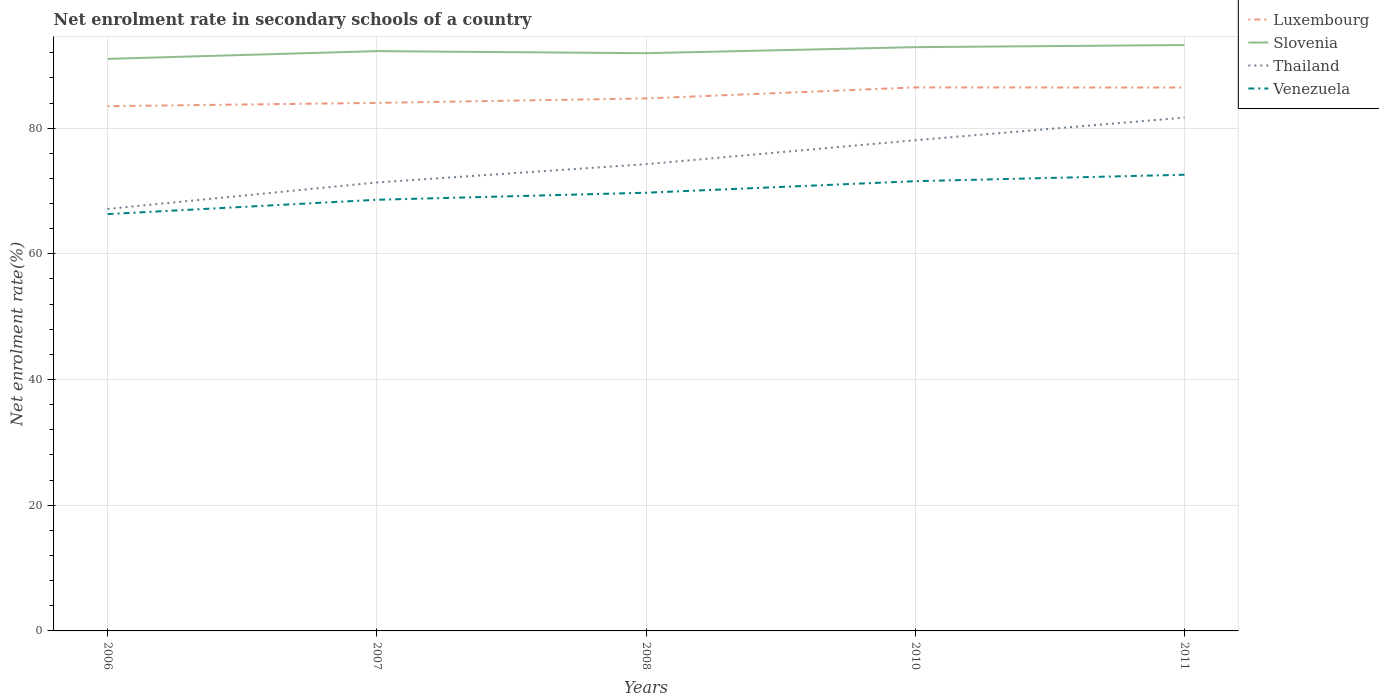How many different coloured lines are there?
Offer a terse response. 4. Does the line corresponding to Venezuela intersect with the line corresponding to Thailand?
Provide a succinct answer. No. Is the number of lines equal to the number of legend labels?
Ensure brevity in your answer.  Yes. Across all years, what is the maximum net enrolment rate in secondary schools in Venezuela?
Ensure brevity in your answer.  66.32. What is the total net enrolment rate in secondary schools in Venezuela in the graph?
Keep it short and to the point. -3.98. What is the difference between the highest and the second highest net enrolment rate in secondary schools in Slovenia?
Offer a very short reply. 2.2. What is the difference between the highest and the lowest net enrolment rate in secondary schools in Venezuela?
Give a very brief answer. 2. Is the net enrolment rate in secondary schools in Slovenia strictly greater than the net enrolment rate in secondary schools in Thailand over the years?
Give a very brief answer. No. How many lines are there?
Provide a short and direct response. 4. How many years are there in the graph?
Your response must be concise. 5. What is the difference between two consecutive major ticks on the Y-axis?
Offer a terse response. 20. Are the values on the major ticks of Y-axis written in scientific E-notation?
Provide a succinct answer. No. Does the graph contain any zero values?
Keep it short and to the point. No. Does the graph contain grids?
Offer a terse response. Yes. How many legend labels are there?
Keep it short and to the point. 4. How are the legend labels stacked?
Keep it short and to the point. Vertical. What is the title of the graph?
Your response must be concise. Net enrolment rate in secondary schools of a country. What is the label or title of the X-axis?
Provide a succinct answer. Years. What is the label or title of the Y-axis?
Ensure brevity in your answer.  Net enrolment rate(%). What is the Net enrolment rate(%) in Luxembourg in 2006?
Your response must be concise. 83.5. What is the Net enrolment rate(%) of Slovenia in 2006?
Make the answer very short. 91.03. What is the Net enrolment rate(%) of Thailand in 2006?
Your response must be concise. 67.15. What is the Net enrolment rate(%) of Venezuela in 2006?
Ensure brevity in your answer.  66.32. What is the Net enrolment rate(%) in Luxembourg in 2007?
Keep it short and to the point. 84.02. What is the Net enrolment rate(%) of Slovenia in 2007?
Make the answer very short. 92.26. What is the Net enrolment rate(%) in Thailand in 2007?
Your response must be concise. 71.36. What is the Net enrolment rate(%) of Venezuela in 2007?
Ensure brevity in your answer.  68.61. What is the Net enrolment rate(%) of Luxembourg in 2008?
Your response must be concise. 84.73. What is the Net enrolment rate(%) in Slovenia in 2008?
Make the answer very short. 91.93. What is the Net enrolment rate(%) of Thailand in 2008?
Provide a succinct answer. 74.27. What is the Net enrolment rate(%) of Venezuela in 2008?
Your answer should be compact. 69.73. What is the Net enrolment rate(%) in Luxembourg in 2010?
Your answer should be very brief. 86.49. What is the Net enrolment rate(%) in Slovenia in 2010?
Provide a succinct answer. 92.89. What is the Net enrolment rate(%) in Thailand in 2010?
Your answer should be very brief. 78.09. What is the Net enrolment rate(%) of Venezuela in 2010?
Give a very brief answer. 71.57. What is the Net enrolment rate(%) in Luxembourg in 2011?
Your answer should be compact. 86.47. What is the Net enrolment rate(%) in Slovenia in 2011?
Your answer should be very brief. 93.23. What is the Net enrolment rate(%) of Thailand in 2011?
Ensure brevity in your answer.  81.69. What is the Net enrolment rate(%) in Venezuela in 2011?
Give a very brief answer. 72.59. Across all years, what is the maximum Net enrolment rate(%) in Luxembourg?
Give a very brief answer. 86.49. Across all years, what is the maximum Net enrolment rate(%) in Slovenia?
Your response must be concise. 93.23. Across all years, what is the maximum Net enrolment rate(%) of Thailand?
Offer a terse response. 81.69. Across all years, what is the maximum Net enrolment rate(%) in Venezuela?
Keep it short and to the point. 72.59. Across all years, what is the minimum Net enrolment rate(%) in Luxembourg?
Offer a very short reply. 83.5. Across all years, what is the minimum Net enrolment rate(%) of Slovenia?
Keep it short and to the point. 91.03. Across all years, what is the minimum Net enrolment rate(%) in Thailand?
Your answer should be very brief. 67.15. Across all years, what is the minimum Net enrolment rate(%) of Venezuela?
Offer a very short reply. 66.32. What is the total Net enrolment rate(%) of Luxembourg in the graph?
Your answer should be very brief. 425.21. What is the total Net enrolment rate(%) in Slovenia in the graph?
Keep it short and to the point. 461.34. What is the total Net enrolment rate(%) of Thailand in the graph?
Offer a terse response. 372.56. What is the total Net enrolment rate(%) of Venezuela in the graph?
Offer a terse response. 348.82. What is the difference between the Net enrolment rate(%) of Luxembourg in 2006 and that in 2007?
Your answer should be very brief. -0.52. What is the difference between the Net enrolment rate(%) of Slovenia in 2006 and that in 2007?
Give a very brief answer. -1.23. What is the difference between the Net enrolment rate(%) in Thailand in 2006 and that in 2007?
Your answer should be very brief. -4.21. What is the difference between the Net enrolment rate(%) of Venezuela in 2006 and that in 2007?
Your answer should be compact. -2.28. What is the difference between the Net enrolment rate(%) of Luxembourg in 2006 and that in 2008?
Ensure brevity in your answer.  -1.23. What is the difference between the Net enrolment rate(%) in Slovenia in 2006 and that in 2008?
Your answer should be compact. -0.9. What is the difference between the Net enrolment rate(%) of Thailand in 2006 and that in 2008?
Keep it short and to the point. -7.12. What is the difference between the Net enrolment rate(%) of Venezuela in 2006 and that in 2008?
Provide a succinct answer. -3.4. What is the difference between the Net enrolment rate(%) of Luxembourg in 2006 and that in 2010?
Give a very brief answer. -2.99. What is the difference between the Net enrolment rate(%) in Slovenia in 2006 and that in 2010?
Your answer should be compact. -1.86. What is the difference between the Net enrolment rate(%) of Thailand in 2006 and that in 2010?
Ensure brevity in your answer.  -10.94. What is the difference between the Net enrolment rate(%) in Venezuela in 2006 and that in 2010?
Give a very brief answer. -5.24. What is the difference between the Net enrolment rate(%) of Luxembourg in 2006 and that in 2011?
Offer a very short reply. -2.97. What is the difference between the Net enrolment rate(%) of Slovenia in 2006 and that in 2011?
Your response must be concise. -2.2. What is the difference between the Net enrolment rate(%) of Thailand in 2006 and that in 2011?
Your answer should be very brief. -14.54. What is the difference between the Net enrolment rate(%) in Venezuela in 2006 and that in 2011?
Offer a terse response. -6.27. What is the difference between the Net enrolment rate(%) in Luxembourg in 2007 and that in 2008?
Provide a succinct answer. -0.71. What is the difference between the Net enrolment rate(%) of Slovenia in 2007 and that in 2008?
Your answer should be very brief. 0.33. What is the difference between the Net enrolment rate(%) in Thailand in 2007 and that in 2008?
Give a very brief answer. -2.91. What is the difference between the Net enrolment rate(%) of Venezuela in 2007 and that in 2008?
Your response must be concise. -1.12. What is the difference between the Net enrolment rate(%) of Luxembourg in 2007 and that in 2010?
Ensure brevity in your answer.  -2.46. What is the difference between the Net enrolment rate(%) in Slovenia in 2007 and that in 2010?
Your response must be concise. -0.63. What is the difference between the Net enrolment rate(%) of Thailand in 2007 and that in 2010?
Provide a short and direct response. -6.72. What is the difference between the Net enrolment rate(%) in Venezuela in 2007 and that in 2010?
Keep it short and to the point. -2.96. What is the difference between the Net enrolment rate(%) in Luxembourg in 2007 and that in 2011?
Provide a succinct answer. -2.44. What is the difference between the Net enrolment rate(%) in Slovenia in 2007 and that in 2011?
Give a very brief answer. -0.97. What is the difference between the Net enrolment rate(%) of Thailand in 2007 and that in 2011?
Give a very brief answer. -10.32. What is the difference between the Net enrolment rate(%) of Venezuela in 2007 and that in 2011?
Your answer should be compact. -3.98. What is the difference between the Net enrolment rate(%) of Luxembourg in 2008 and that in 2010?
Your answer should be very brief. -1.75. What is the difference between the Net enrolment rate(%) in Slovenia in 2008 and that in 2010?
Offer a very short reply. -0.96. What is the difference between the Net enrolment rate(%) of Thailand in 2008 and that in 2010?
Offer a terse response. -3.81. What is the difference between the Net enrolment rate(%) of Venezuela in 2008 and that in 2010?
Offer a very short reply. -1.84. What is the difference between the Net enrolment rate(%) in Luxembourg in 2008 and that in 2011?
Give a very brief answer. -1.73. What is the difference between the Net enrolment rate(%) in Slovenia in 2008 and that in 2011?
Give a very brief answer. -1.3. What is the difference between the Net enrolment rate(%) in Thailand in 2008 and that in 2011?
Ensure brevity in your answer.  -7.41. What is the difference between the Net enrolment rate(%) of Venezuela in 2008 and that in 2011?
Give a very brief answer. -2.86. What is the difference between the Net enrolment rate(%) in Luxembourg in 2010 and that in 2011?
Offer a very short reply. 0.02. What is the difference between the Net enrolment rate(%) of Slovenia in 2010 and that in 2011?
Offer a very short reply. -0.34. What is the difference between the Net enrolment rate(%) in Thailand in 2010 and that in 2011?
Your response must be concise. -3.6. What is the difference between the Net enrolment rate(%) in Venezuela in 2010 and that in 2011?
Offer a very short reply. -1.03. What is the difference between the Net enrolment rate(%) in Luxembourg in 2006 and the Net enrolment rate(%) in Slovenia in 2007?
Make the answer very short. -8.76. What is the difference between the Net enrolment rate(%) in Luxembourg in 2006 and the Net enrolment rate(%) in Thailand in 2007?
Ensure brevity in your answer.  12.14. What is the difference between the Net enrolment rate(%) in Luxembourg in 2006 and the Net enrolment rate(%) in Venezuela in 2007?
Provide a succinct answer. 14.89. What is the difference between the Net enrolment rate(%) of Slovenia in 2006 and the Net enrolment rate(%) of Thailand in 2007?
Offer a very short reply. 19.66. What is the difference between the Net enrolment rate(%) of Slovenia in 2006 and the Net enrolment rate(%) of Venezuela in 2007?
Provide a short and direct response. 22.42. What is the difference between the Net enrolment rate(%) of Thailand in 2006 and the Net enrolment rate(%) of Venezuela in 2007?
Keep it short and to the point. -1.46. What is the difference between the Net enrolment rate(%) of Luxembourg in 2006 and the Net enrolment rate(%) of Slovenia in 2008?
Provide a short and direct response. -8.43. What is the difference between the Net enrolment rate(%) of Luxembourg in 2006 and the Net enrolment rate(%) of Thailand in 2008?
Give a very brief answer. 9.23. What is the difference between the Net enrolment rate(%) of Luxembourg in 2006 and the Net enrolment rate(%) of Venezuela in 2008?
Offer a very short reply. 13.77. What is the difference between the Net enrolment rate(%) of Slovenia in 2006 and the Net enrolment rate(%) of Thailand in 2008?
Offer a terse response. 16.75. What is the difference between the Net enrolment rate(%) of Slovenia in 2006 and the Net enrolment rate(%) of Venezuela in 2008?
Provide a short and direct response. 21.3. What is the difference between the Net enrolment rate(%) in Thailand in 2006 and the Net enrolment rate(%) in Venezuela in 2008?
Provide a short and direct response. -2.58. What is the difference between the Net enrolment rate(%) of Luxembourg in 2006 and the Net enrolment rate(%) of Slovenia in 2010?
Ensure brevity in your answer.  -9.39. What is the difference between the Net enrolment rate(%) of Luxembourg in 2006 and the Net enrolment rate(%) of Thailand in 2010?
Offer a very short reply. 5.41. What is the difference between the Net enrolment rate(%) of Luxembourg in 2006 and the Net enrolment rate(%) of Venezuela in 2010?
Ensure brevity in your answer.  11.93. What is the difference between the Net enrolment rate(%) of Slovenia in 2006 and the Net enrolment rate(%) of Thailand in 2010?
Keep it short and to the point. 12.94. What is the difference between the Net enrolment rate(%) of Slovenia in 2006 and the Net enrolment rate(%) of Venezuela in 2010?
Provide a succinct answer. 19.46. What is the difference between the Net enrolment rate(%) in Thailand in 2006 and the Net enrolment rate(%) in Venezuela in 2010?
Give a very brief answer. -4.42. What is the difference between the Net enrolment rate(%) of Luxembourg in 2006 and the Net enrolment rate(%) of Slovenia in 2011?
Your answer should be compact. -9.73. What is the difference between the Net enrolment rate(%) of Luxembourg in 2006 and the Net enrolment rate(%) of Thailand in 2011?
Your response must be concise. 1.81. What is the difference between the Net enrolment rate(%) of Luxembourg in 2006 and the Net enrolment rate(%) of Venezuela in 2011?
Your answer should be compact. 10.91. What is the difference between the Net enrolment rate(%) of Slovenia in 2006 and the Net enrolment rate(%) of Thailand in 2011?
Provide a short and direct response. 9.34. What is the difference between the Net enrolment rate(%) in Slovenia in 2006 and the Net enrolment rate(%) in Venezuela in 2011?
Give a very brief answer. 18.44. What is the difference between the Net enrolment rate(%) in Thailand in 2006 and the Net enrolment rate(%) in Venezuela in 2011?
Offer a terse response. -5.44. What is the difference between the Net enrolment rate(%) in Luxembourg in 2007 and the Net enrolment rate(%) in Slovenia in 2008?
Your answer should be very brief. -7.91. What is the difference between the Net enrolment rate(%) in Luxembourg in 2007 and the Net enrolment rate(%) in Thailand in 2008?
Offer a very short reply. 9.75. What is the difference between the Net enrolment rate(%) in Luxembourg in 2007 and the Net enrolment rate(%) in Venezuela in 2008?
Offer a very short reply. 14.3. What is the difference between the Net enrolment rate(%) in Slovenia in 2007 and the Net enrolment rate(%) in Thailand in 2008?
Offer a very short reply. 17.99. What is the difference between the Net enrolment rate(%) of Slovenia in 2007 and the Net enrolment rate(%) of Venezuela in 2008?
Offer a very short reply. 22.53. What is the difference between the Net enrolment rate(%) in Thailand in 2007 and the Net enrolment rate(%) in Venezuela in 2008?
Offer a terse response. 1.63. What is the difference between the Net enrolment rate(%) of Luxembourg in 2007 and the Net enrolment rate(%) of Slovenia in 2010?
Your answer should be compact. -8.87. What is the difference between the Net enrolment rate(%) in Luxembourg in 2007 and the Net enrolment rate(%) in Thailand in 2010?
Your answer should be compact. 5.94. What is the difference between the Net enrolment rate(%) in Luxembourg in 2007 and the Net enrolment rate(%) in Venezuela in 2010?
Offer a terse response. 12.46. What is the difference between the Net enrolment rate(%) in Slovenia in 2007 and the Net enrolment rate(%) in Thailand in 2010?
Provide a short and direct response. 14.17. What is the difference between the Net enrolment rate(%) in Slovenia in 2007 and the Net enrolment rate(%) in Venezuela in 2010?
Make the answer very short. 20.7. What is the difference between the Net enrolment rate(%) of Thailand in 2007 and the Net enrolment rate(%) of Venezuela in 2010?
Ensure brevity in your answer.  -0.2. What is the difference between the Net enrolment rate(%) of Luxembourg in 2007 and the Net enrolment rate(%) of Slovenia in 2011?
Make the answer very short. -9.21. What is the difference between the Net enrolment rate(%) in Luxembourg in 2007 and the Net enrolment rate(%) in Thailand in 2011?
Offer a terse response. 2.34. What is the difference between the Net enrolment rate(%) of Luxembourg in 2007 and the Net enrolment rate(%) of Venezuela in 2011?
Give a very brief answer. 11.43. What is the difference between the Net enrolment rate(%) in Slovenia in 2007 and the Net enrolment rate(%) in Thailand in 2011?
Provide a short and direct response. 10.57. What is the difference between the Net enrolment rate(%) in Slovenia in 2007 and the Net enrolment rate(%) in Venezuela in 2011?
Your answer should be compact. 19.67. What is the difference between the Net enrolment rate(%) in Thailand in 2007 and the Net enrolment rate(%) in Venezuela in 2011?
Ensure brevity in your answer.  -1.23. What is the difference between the Net enrolment rate(%) of Luxembourg in 2008 and the Net enrolment rate(%) of Slovenia in 2010?
Give a very brief answer. -8.16. What is the difference between the Net enrolment rate(%) in Luxembourg in 2008 and the Net enrolment rate(%) in Thailand in 2010?
Your answer should be very brief. 6.65. What is the difference between the Net enrolment rate(%) of Luxembourg in 2008 and the Net enrolment rate(%) of Venezuela in 2010?
Your response must be concise. 13.17. What is the difference between the Net enrolment rate(%) of Slovenia in 2008 and the Net enrolment rate(%) of Thailand in 2010?
Your answer should be compact. 13.85. What is the difference between the Net enrolment rate(%) of Slovenia in 2008 and the Net enrolment rate(%) of Venezuela in 2010?
Make the answer very short. 20.37. What is the difference between the Net enrolment rate(%) of Thailand in 2008 and the Net enrolment rate(%) of Venezuela in 2010?
Your answer should be compact. 2.71. What is the difference between the Net enrolment rate(%) in Luxembourg in 2008 and the Net enrolment rate(%) in Slovenia in 2011?
Provide a succinct answer. -8.5. What is the difference between the Net enrolment rate(%) of Luxembourg in 2008 and the Net enrolment rate(%) of Thailand in 2011?
Keep it short and to the point. 3.05. What is the difference between the Net enrolment rate(%) of Luxembourg in 2008 and the Net enrolment rate(%) of Venezuela in 2011?
Offer a very short reply. 12.14. What is the difference between the Net enrolment rate(%) in Slovenia in 2008 and the Net enrolment rate(%) in Thailand in 2011?
Ensure brevity in your answer.  10.24. What is the difference between the Net enrolment rate(%) of Slovenia in 2008 and the Net enrolment rate(%) of Venezuela in 2011?
Provide a succinct answer. 19.34. What is the difference between the Net enrolment rate(%) of Thailand in 2008 and the Net enrolment rate(%) of Venezuela in 2011?
Your answer should be compact. 1.68. What is the difference between the Net enrolment rate(%) of Luxembourg in 2010 and the Net enrolment rate(%) of Slovenia in 2011?
Your response must be concise. -6.75. What is the difference between the Net enrolment rate(%) of Luxembourg in 2010 and the Net enrolment rate(%) of Thailand in 2011?
Your response must be concise. 4.8. What is the difference between the Net enrolment rate(%) in Luxembourg in 2010 and the Net enrolment rate(%) in Venezuela in 2011?
Give a very brief answer. 13.89. What is the difference between the Net enrolment rate(%) in Slovenia in 2010 and the Net enrolment rate(%) in Thailand in 2011?
Ensure brevity in your answer.  11.21. What is the difference between the Net enrolment rate(%) of Slovenia in 2010 and the Net enrolment rate(%) of Venezuela in 2011?
Offer a very short reply. 20.3. What is the difference between the Net enrolment rate(%) in Thailand in 2010 and the Net enrolment rate(%) in Venezuela in 2011?
Your response must be concise. 5.5. What is the average Net enrolment rate(%) in Luxembourg per year?
Give a very brief answer. 85.04. What is the average Net enrolment rate(%) in Slovenia per year?
Offer a terse response. 92.27. What is the average Net enrolment rate(%) of Thailand per year?
Offer a very short reply. 74.51. What is the average Net enrolment rate(%) in Venezuela per year?
Make the answer very short. 69.76. In the year 2006, what is the difference between the Net enrolment rate(%) of Luxembourg and Net enrolment rate(%) of Slovenia?
Make the answer very short. -7.53. In the year 2006, what is the difference between the Net enrolment rate(%) in Luxembourg and Net enrolment rate(%) in Thailand?
Offer a terse response. 16.35. In the year 2006, what is the difference between the Net enrolment rate(%) in Luxembourg and Net enrolment rate(%) in Venezuela?
Keep it short and to the point. 17.18. In the year 2006, what is the difference between the Net enrolment rate(%) in Slovenia and Net enrolment rate(%) in Thailand?
Offer a very short reply. 23.88. In the year 2006, what is the difference between the Net enrolment rate(%) in Slovenia and Net enrolment rate(%) in Venezuela?
Your response must be concise. 24.7. In the year 2006, what is the difference between the Net enrolment rate(%) in Thailand and Net enrolment rate(%) in Venezuela?
Make the answer very short. 0.82. In the year 2007, what is the difference between the Net enrolment rate(%) in Luxembourg and Net enrolment rate(%) in Slovenia?
Provide a short and direct response. -8.24. In the year 2007, what is the difference between the Net enrolment rate(%) of Luxembourg and Net enrolment rate(%) of Thailand?
Provide a succinct answer. 12.66. In the year 2007, what is the difference between the Net enrolment rate(%) in Luxembourg and Net enrolment rate(%) in Venezuela?
Offer a terse response. 15.42. In the year 2007, what is the difference between the Net enrolment rate(%) of Slovenia and Net enrolment rate(%) of Thailand?
Make the answer very short. 20.9. In the year 2007, what is the difference between the Net enrolment rate(%) in Slovenia and Net enrolment rate(%) in Venezuela?
Offer a very short reply. 23.65. In the year 2007, what is the difference between the Net enrolment rate(%) of Thailand and Net enrolment rate(%) of Venezuela?
Keep it short and to the point. 2.75. In the year 2008, what is the difference between the Net enrolment rate(%) of Luxembourg and Net enrolment rate(%) of Slovenia?
Offer a very short reply. -7.2. In the year 2008, what is the difference between the Net enrolment rate(%) of Luxembourg and Net enrolment rate(%) of Thailand?
Your answer should be compact. 10.46. In the year 2008, what is the difference between the Net enrolment rate(%) of Luxembourg and Net enrolment rate(%) of Venezuela?
Provide a short and direct response. 15.01. In the year 2008, what is the difference between the Net enrolment rate(%) of Slovenia and Net enrolment rate(%) of Thailand?
Ensure brevity in your answer.  17.66. In the year 2008, what is the difference between the Net enrolment rate(%) of Slovenia and Net enrolment rate(%) of Venezuela?
Your answer should be compact. 22.2. In the year 2008, what is the difference between the Net enrolment rate(%) of Thailand and Net enrolment rate(%) of Venezuela?
Your answer should be very brief. 4.54. In the year 2010, what is the difference between the Net enrolment rate(%) of Luxembourg and Net enrolment rate(%) of Slovenia?
Provide a short and direct response. -6.41. In the year 2010, what is the difference between the Net enrolment rate(%) in Luxembourg and Net enrolment rate(%) in Thailand?
Your answer should be very brief. 8.4. In the year 2010, what is the difference between the Net enrolment rate(%) in Luxembourg and Net enrolment rate(%) in Venezuela?
Ensure brevity in your answer.  14.92. In the year 2010, what is the difference between the Net enrolment rate(%) in Slovenia and Net enrolment rate(%) in Thailand?
Provide a succinct answer. 14.81. In the year 2010, what is the difference between the Net enrolment rate(%) of Slovenia and Net enrolment rate(%) of Venezuela?
Offer a terse response. 21.33. In the year 2010, what is the difference between the Net enrolment rate(%) in Thailand and Net enrolment rate(%) in Venezuela?
Your answer should be compact. 6.52. In the year 2011, what is the difference between the Net enrolment rate(%) of Luxembourg and Net enrolment rate(%) of Slovenia?
Offer a very short reply. -6.76. In the year 2011, what is the difference between the Net enrolment rate(%) of Luxembourg and Net enrolment rate(%) of Thailand?
Provide a succinct answer. 4.78. In the year 2011, what is the difference between the Net enrolment rate(%) in Luxembourg and Net enrolment rate(%) in Venezuela?
Provide a short and direct response. 13.88. In the year 2011, what is the difference between the Net enrolment rate(%) in Slovenia and Net enrolment rate(%) in Thailand?
Make the answer very short. 11.54. In the year 2011, what is the difference between the Net enrolment rate(%) of Slovenia and Net enrolment rate(%) of Venezuela?
Make the answer very short. 20.64. In the year 2011, what is the difference between the Net enrolment rate(%) in Thailand and Net enrolment rate(%) in Venezuela?
Make the answer very short. 9.1. What is the ratio of the Net enrolment rate(%) of Slovenia in 2006 to that in 2007?
Offer a terse response. 0.99. What is the ratio of the Net enrolment rate(%) of Thailand in 2006 to that in 2007?
Keep it short and to the point. 0.94. What is the ratio of the Net enrolment rate(%) in Venezuela in 2006 to that in 2007?
Your answer should be compact. 0.97. What is the ratio of the Net enrolment rate(%) in Luxembourg in 2006 to that in 2008?
Provide a short and direct response. 0.99. What is the ratio of the Net enrolment rate(%) in Slovenia in 2006 to that in 2008?
Offer a very short reply. 0.99. What is the ratio of the Net enrolment rate(%) of Thailand in 2006 to that in 2008?
Make the answer very short. 0.9. What is the ratio of the Net enrolment rate(%) of Venezuela in 2006 to that in 2008?
Your answer should be very brief. 0.95. What is the ratio of the Net enrolment rate(%) of Luxembourg in 2006 to that in 2010?
Your answer should be very brief. 0.97. What is the ratio of the Net enrolment rate(%) of Slovenia in 2006 to that in 2010?
Provide a succinct answer. 0.98. What is the ratio of the Net enrolment rate(%) of Thailand in 2006 to that in 2010?
Make the answer very short. 0.86. What is the ratio of the Net enrolment rate(%) of Venezuela in 2006 to that in 2010?
Offer a terse response. 0.93. What is the ratio of the Net enrolment rate(%) in Luxembourg in 2006 to that in 2011?
Provide a succinct answer. 0.97. What is the ratio of the Net enrolment rate(%) of Slovenia in 2006 to that in 2011?
Make the answer very short. 0.98. What is the ratio of the Net enrolment rate(%) in Thailand in 2006 to that in 2011?
Ensure brevity in your answer.  0.82. What is the ratio of the Net enrolment rate(%) of Venezuela in 2006 to that in 2011?
Provide a succinct answer. 0.91. What is the ratio of the Net enrolment rate(%) of Luxembourg in 2007 to that in 2008?
Give a very brief answer. 0.99. What is the ratio of the Net enrolment rate(%) of Slovenia in 2007 to that in 2008?
Your answer should be compact. 1. What is the ratio of the Net enrolment rate(%) in Thailand in 2007 to that in 2008?
Give a very brief answer. 0.96. What is the ratio of the Net enrolment rate(%) in Venezuela in 2007 to that in 2008?
Ensure brevity in your answer.  0.98. What is the ratio of the Net enrolment rate(%) of Luxembourg in 2007 to that in 2010?
Provide a short and direct response. 0.97. What is the ratio of the Net enrolment rate(%) of Slovenia in 2007 to that in 2010?
Make the answer very short. 0.99. What is the ratio of the Net enrolment rate(%) of Thailand in 2007 to that in 2010?
Make the answer very short. 0.91. What is the ratio of the Net enrolment rate(%) of Venezuela in 2007 to that in 2010?
Offer a very short reply. 0.96. What is the ratio of the Net enrolment rate(%) of Luxembourg in 2007 to that in 2011?
Provide a short and direct response. 0.97. What is the ratio of the Net enrolment rate(%) of Thailand in 2007 to that in 2011?
Provide a short and direct response. 0.87. What is the ratio of the Net enrolment rate(%) in Venezuela in 2007 to that in 2011?
Make the answer very short. 0.95. What is the ratio of the Net enrolment rate(%) in Luxembourg in 2008 to that in 2010?
Offer a very short reply. 0.98. What is the ratio of the Net enrolment rate(%) in Slovenia in 2008 to that in 2010?
Make the answer very short. 0.99. What is the ratio of the Net enrolment rate(%) in Thailand in 2008 to that in 2010?
Your answer should be compact. 0.95. What is the ratio of the Net enrolment rate(%) of Venezuela in 2008 to that in 2010?
Ensure brevity in your answer.  0.97. What is the ratio of the Net enrolment rate(%) of Luxembourg in 2008 to that in 2011?
Offer a terse response. 0.98. What is the ratio of the Net enrolment rate(%) of Slovenia in 2008 to that in 2011?
Your response must be concise. 0.99. What is the ratio of the Net enrolment rate(%) of Thailand in 2008 to that in 2011?
Make the answer very short. 0.91. What is the ratio of the Net enrolment rate(%) of Venezuela in 2008 to that in 2011?
Offer a very short reply. 0.96. What is the ratio of the Net enrolment rate(%) in Luxembourg in 2010 to that in 2011?
Your answer should be compact. 1. What is the ratio of the Net enrolment rate(%) of Thailand in 2010 to that in 2011?
Provide a succinct answer. 0.96. What is the ratio of the Net enrolment rate(%) in Venezuela in 2010 to that in 2011?
Offer a very short reply. 0.99. What is the difference between the highest and the second highest Net enrolment rate(%) in Luxembourg?
Your answer should be very brief. 0.02. What is the difference between the highest and the second highest Net enrolment rate(%) of Slovenia?
Your answer should be very brief. 0.34. What is the difference between the highest and the second highest Net enrolment rate(%) of Thailand?
Your answer should be very brief. 3.6. What is the difference between the highest and the second highest Net enrolment rate(%) in Venezuela?
Keep it short and to the point. 1.03. What is the difference between the highest and the lowest Net enrolment rate(%) in Luxembourg?
Give a very brief answer. 2.99. What is the difference between the highest and the lowest Net enrolment rate(%) in Slovenia?
Ensure brevity in your answer.  2.2. What is the difference between the highest and the lowest Net enrolment rate(%) of Thailand?
Your response must be concise. 14.54. What is the difference between the highest and the lowest Net enrolment rate(%) of Venezuela?
Keep it short and to the point. 6.27. 